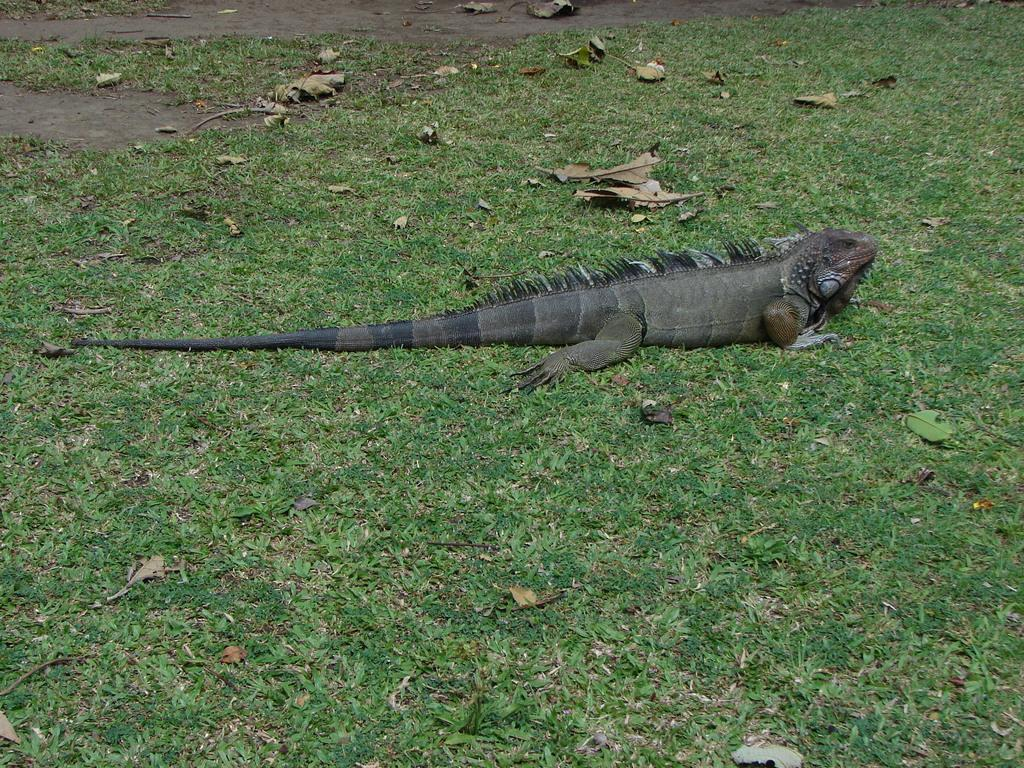What type of animal is in the image? There is a reptile in the image. Where is the reptile located in the image? The reptile is on the ground. In which direction is the reptile facing? The reptile is facing towards the right side. What type of vegetation can be seen in the image? There is green color grass in the image. What else can be found on the ground in the image? There are leaves on the ground in the image. What type of plant is being celebrated in the image? There is no plant being celebrated in the image; it features a reptile on the ground. What room is the reptile located in the image? The image does not specify a room; it only shows the reptile on the ground with grass and leaves. 